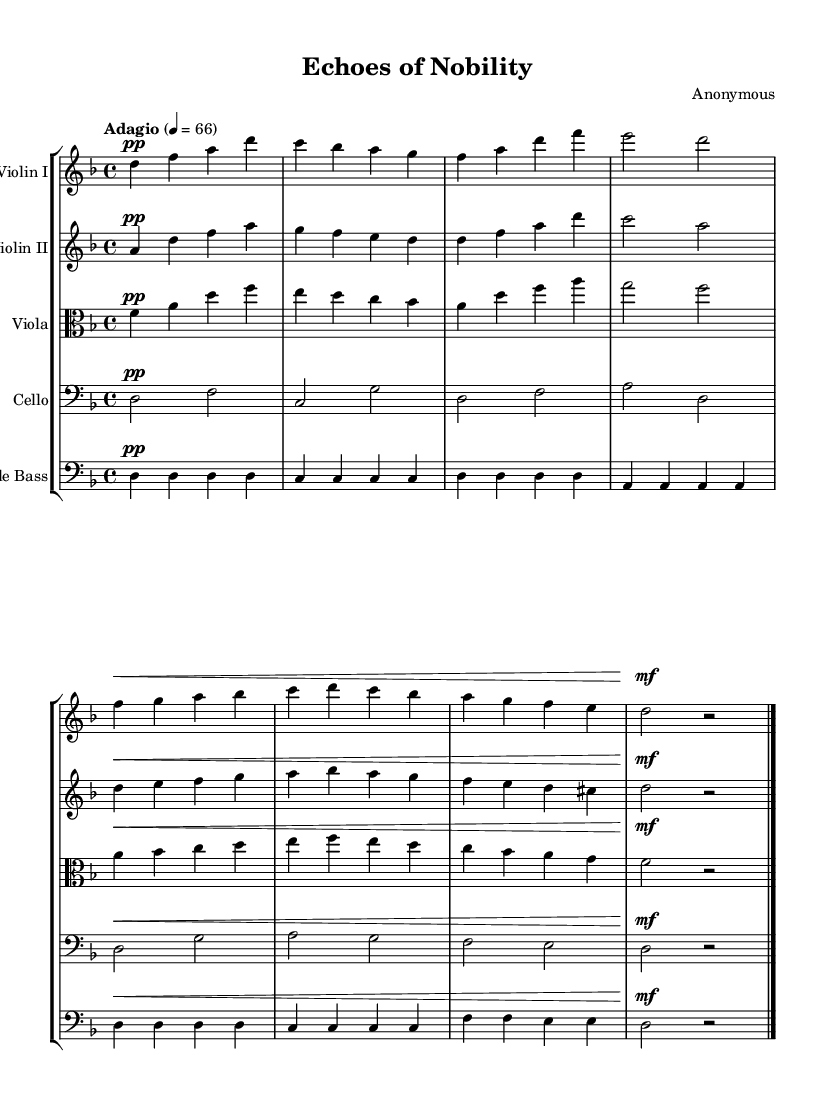What is the key signature of this music? The key signature indicates that there are two flats, which is characteristic of A-flat major or F minor. However, since this piece is in D minor, it has one flat, B-flat.
Answer: D minor What is the time signature of the piece? The time signature is found at the beginning of the piece and shows a 4 over 4, indicating four beats per measure.
Answer: 4/4 What is the tempo marking? The tempo marking is specified in the score as "Adagio," which indicates a slow tempo. The metronome marking of 66 beats per minute further clarifies this tempo.
Answer: Adagio Which instrument plays the highest notes in this score? By examining the melodies on the staff, the first violin has the highest pitches throughout the piece, playing notes around the D and A above middle C.
Answer: Violin I How many instrumental parts are included in this composition? By counting the number of staves in the score, we see five distinct instruments listed: Violin I, Violin II, Viola, Cello, and Double Bass.
Answer: Five What dynamic marking is predominantly used in the first half of this composition? The dynamic markings indicate that the majority of the piece is marked as "pp," which signifies a very soft performance. This contrasts with sections that have a dynamic marking of "mf."
Answer: pp Which instrument has the lowest range in this score? The Double Bass is designed to play the lowest pitches, as evidenced by its clef, which indicates bass notes, and the sounds it produces being the lowest in the score.
Answer: Double Bass 